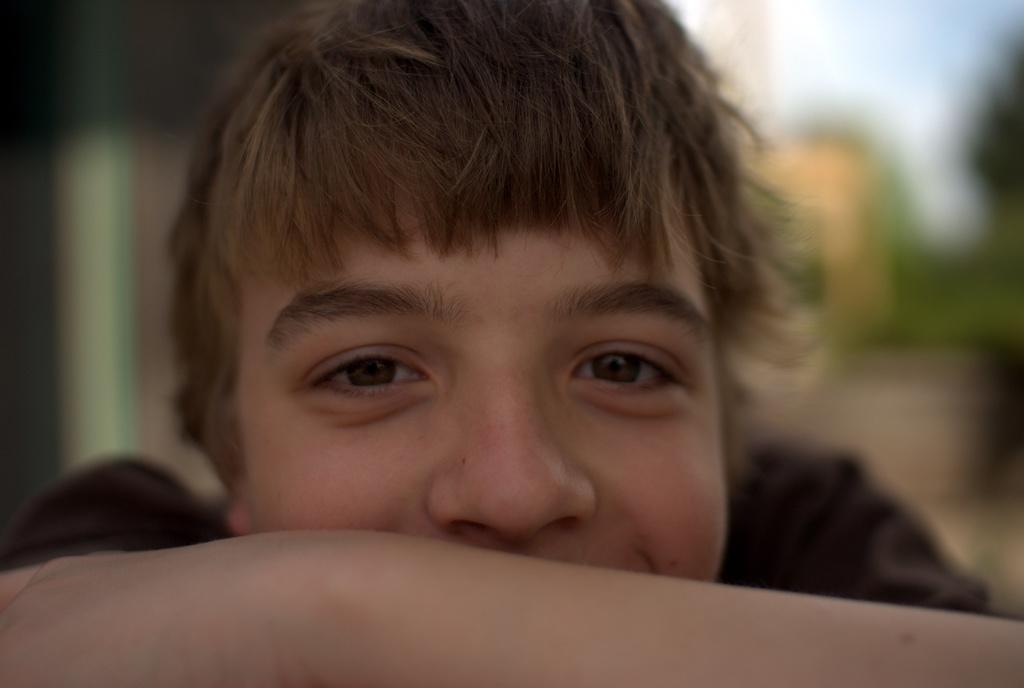What is the main subject of the image? There is a boy in the image. Can you describe the boy's appearance? The boy has golden hair. What is the boy's expression in the image? The boy is smiling. How would you describe the background of the image? The background of the image is blurry. What type of cord is the boy holding in the image? There is no cord present in the image. Can you hear the boy's laughter in the image? The image is a still photograph and does not contain any sound, so it is not possible to hear the boy's laughter. 